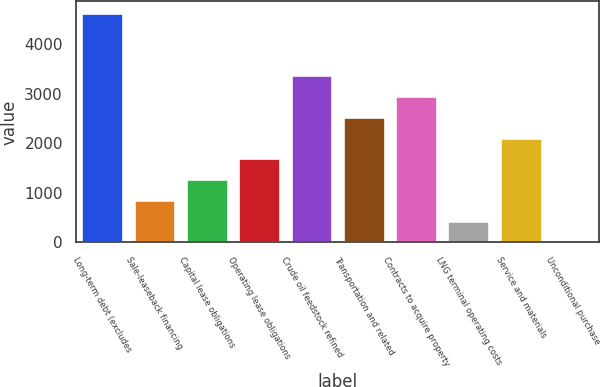Convert chart. <chart><loc_0><loc_0><loc_500><loc_500><bar_chart><fcel>Long-term debt (excludes<fcel>Sale-leaseback financing<fcel>Capital lease obligations<fcel>Operating lease obligations<fcel>Crude oil feedstock refined<fcel>Transportation and related<fcel>Contracts to acquire property<fcel>LNG terminal operating costs<fcel>Service and materials<fcel>Unconditional purchase<nl><fcel>4628.5<fcel>853<fcel>1272.5<fcel>1692<fcel>3370<fcel>2531<fcel>2950.5<fcel>433.5<fcel>2111.5<fcel>14<nl></chart> 